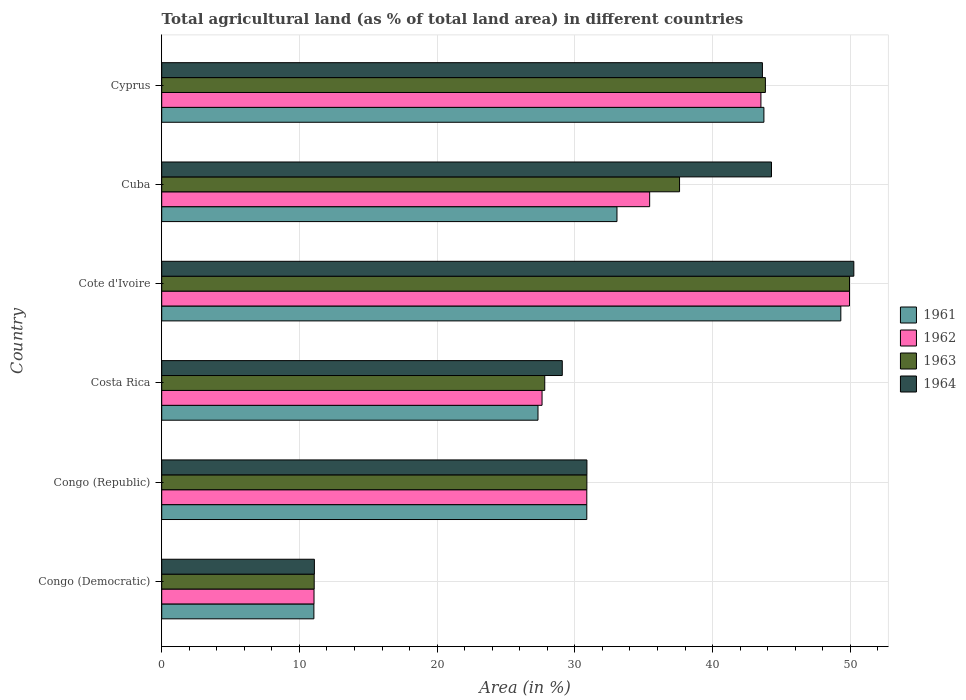How many groups of bars are there?
Provide a short and direct response. 6. How many bars are there on the 6th tick from the top?
Your response must be concise. 4. How many bars are there on the 2nd tick from the bottom?
Keep it short and to the point. 4. What is the label of the 5th group of bars from the top?
Keep it short and to the point. Congo (Republic). In how many cases, is the number of bars for a given country not equal to the number of legend labels?
Provide a short and direct response. 0. What is the percentage of agricultural land in 1961 in Congo (Republic)?
Your response must be concise. 30.86. Across all countries, what is the maximum percentage of agricultural land in 1961?
Ensure brevity in your answer.  49.31. Across all countries, what is the minimum percentage of agricultural land in 1963?
Provide a short and direct response. 11.07. In which country was the percentage of agricultural land in 1962 maximum?
Offer a very short reply. Cote d'Ivoire. In which country was the percentage of agricultural land in 1963 minimum?
Give a very brief answer. Congo (Democratic). What is the total percentage of agricultural land in 1962 in the graph?
Offer a terse response. 198.41. What is the difference between the percentage of agricultural land in 1961 in Congo (Republic) and that in Costa Rica?
Keep it short and to the point. 3.54. What is the difference between the percentage of agricultural land in 1961 in Congo (Republic) and the percentage of agricultural land in 1964 in Cyprus?
Your response must be concise. -12.75. What is the average percentage of agricultural land in 1963 per country?
Your response must be concise. 33.52. What is the difference between the percentage of agricultural land in 1961 and percentage of agricultural land in 1963 in Cyprus?
Your answer should be compact. -0.11. What is the ratio of the percentage of agricultural land in 1962 in Costa Rica to that in Cyprus?
Your response must be concise. 0.63. Is the percentage of agricultural land in 1961 in Cote d'Ivoire less than that in Cuba?
Your answer should be compact. No. What is the difference between the highest and the second highest percentage of agricultural land in 1964?
Provide a short and direct response. 5.98. What is the difference between the highest and the lowest percentage of agricultural land in 1961?
Your response must be concise. 38.26. Is the sum of the percentage of agricultural land in 1962 in Congo (Democratic) and Cuba greater than the maximum percentage of agricultural land in 1961 across all countries?
Your response must be concise. No. Is it the case that in every country, the sum of the percentage of agricultural land in 1962 and percentage of agricultural land in 1964 is greater than the sum of percentage of agricultural land in 1961 and percentage of agricultural land in 1963?
Provide a succinct answer. No. What does the 3rd bar from the top in Cyprus represents?
Offer a very short reply. 1962. How many bars are there?
Your response must be concise. 24. Are all the bars in the graph horizontal?
Your answer should be compact. Yes. Are the values on the major ticks of X-axis written in scientific E-notation?
Offer a terse response. No. Does the graph contain any zero values?
Offer a very short reply. No. Does the graph contain grids?
Your answer should be compact. Yes. What is the title of the graph?
Provide a succinct answer. Total agricultural land (as % of total land area) in different countries. Does "1965" appear as one of the legend labels in the graph?
Make the answer very short. No. What is the label or title of the X-axis?
Your answer should be compact. Area (in %). What is the Area (in %) of 1961 in Congo (Democratic)?
Offer a very short reply. 11.05. What is the Area (in %) of 1962 in Congo (Democratic)?
Provide a succinct answer. 11.06. What is the Area (in %) of 1963 in Congo (Democratic)?
Offer a terse response. 11.07. What is the Area (in %) of 1964 in Congo (Democratic)?
Give a very brief answer. 11.08. What is the Area (in %) in 1961 in Congo (Republic)?
Your response must be concise. 30.86. What is the Area (in %) of 1962 in Congo (Republic)?
Offer a terse response. 30.86. What is the Area (in %) of 1963 in Congo (Republic)?
Make the answer very short. 30.87. What is the Area (in %) of 1964 in Congo (Republic)?
Your response must be concise. 30.87. What is the Area (in %) of 1961 in Costa Rica?
Your response must be concise. 27.32. What is the Area (in %) of 1962 in Costa Rica?
Offer a terse response. 27.61. What is the Area (in %) of 1963 in Costa Rica?
Offer a very short reply. 27.81. What is the Area (in %) in 1964 in Costa Rica?
Your answer should be compact. 29.08. What is the Area (in %) in 1961 in Cote d'Ivoire?
Keep it short and to the point. 49.31. What is the Area (in %) of 1962 in Cote d'Ivoire?
Offer a very short reply. 49.94. What is the Area (in %) of 1963 in Cote d'Ivoire?
Keep it short and to the point. 49.94. What is the Area (in %) in 1964 in Cote d'Ivoire?
Your response must be concise. 50.25. What is the Area (in %) of 1961 in Cuba?
Your answer should be compact. 33.05. What is the Area (in %) in 1962 in Cuba?
Provide a short and direct response. 35.43. What is the Area (in %) in 1963 in Cuba?
Make the answer very short. 37.6. What is the Area (in %) of 1964 in Cuba?
Your answer should be very brief. 44.27. What is the Area (in %) of 1961 in Cyprus?
Ensure brevity in your answer.  43.72. What is the Area (in %) of 1962 in Cyprus?
Provide a short and direct response. 43.51. What is the Area (in %) in 1963 in Cyprus?
Keep it short and to the point. 43.83. What is the Area (in %) of 1964 in Cyprus?
Your response must be concise. 43.61. Across all countries, what is the maximum Area (in %) in 1961?
Provide a succinct answer. 49.31. Across all countries, what is the maximum Area (in %) in 1962?
Give a very brief answer. 49.94. Across all countries, what is the maximum Area (in %) of 1963?
Provide a short and direct response. 49.94. Across all countries, what is the maximum Area (in %) in 1964?
Give a very brief answer. 50.25. Across all countries, what is the minimum Area (in %) of 1961?
Give a very brief answer. 11.05. Across all countries, what is the minimum Area (in %) of 1962?
Offer a terse response. 11.06. Across all countries, what is the minimum Area (in %) in 1963?
Offer a terse response. 11.07. Across all countries, what is the minimum Area (in %) of 1964?
Your answer should be compact. 11.08. What is the total Area (in %) of 1961 in the graph?
Ensure brevity in your answer.  195.32. What is the total Area (in %) of 1962 in the graph?
Offer a very short reply. 198.41. What is the total Area (in %) of 1963 in the graph?
Ensure brevity in your answer.  201.12. What is the total Area (in %) of 1964 in the graph?
Provide a short and direct response. 209.18. What is the difference between the Area (in %) of 1961 in Congo (Democratic) and that in Congo (Republic)?
Provide a succinct answer. -19.81. What is the difference between the Area (in %) of 1962 in Congo (Democratic) and that in Congo (Republic)?
Your answer should be compact. -19.81. What is the difference between the Area (in %) in 1963 in Congo (Democratic) and that in Congo (Republic)?
Offer a terse response. -19.8. What is the difference between the Area (in %) in 1964 in Congo (Democratic) and that in Congo (Republic)?
Provide a succinct answer. -19.79. What is the difference between the Area (in %) in 1961 in Congo (Democratic) and that in Costa Rica?
Ensure brevity in your answer.  -16.27. What is the difference between the Area (in %) of 1962 in Congo (Democratic) and that in Costa Rica?
Offer a terse response. -16.56. What is the difference between the Area (in %) in 1963 in Congo (Democratic) and that in Costa Rica?
Give a very brief answer. -16.74. What is the difference between the Area (in %) in 1964 in Congo (Democratic) and that in Costa Rica?
Your answer should be very brief. -18. What is the difference between the Area (in %) of 1961 in Congo (Democratic) and that in Cote d'Ivoire?
Offer a terse response. -38.26. What is the difference between the Area (in %) in 1962 in Congo (Democratic) and that in Cote d'Ivoire?
Offer a very short reply. -38.88. What is the difference between the Area (in %) in 1963 in Congo (Democratic) and that in Cote d'Ivoire?
Your answer should be compact. -38.87. What is the difference between the Area (in %) of 1964 in Congo (Democratic) and that in Cote d'Ivoire?
Give a very brief answer. -39.17. What is the difference between the Area (in %) of 1961 in Congo (Democratic) and that in Cuba?
Provide a succinct answer. -22. What is the difference between the Area (in %) in 1962 in Congo (Democratic) and that in Cuba?
Provide a short and direct response. -24.37. What is the difference between the Area (in %) in 1963 in Congo (Democratic) and that in Cuba?
Keep it short and to the point. -26.53. What is the difference between the Area (in %) in 1964 in Congo (Democratic) and that in Cuba?
Provide a succinct answer. -33.19. What is the difference between the Area (in %) in 1961 in Congo (Democratic) and that in Cyprus?
Your answer should be compact. -32.67. What is the difference between the Area (in %) in 1962 in Congo (Democratic) and that in Cyprus?
Make the answer very short. -32.45. What is the difference between the Area (in %) of 1963 in Congo (Democratic) and that in Cyprus?
Your answer should be compact. -32.76. What is the difference between the Area (in %) in 1964 in Congo (Democratic) and that in Cyprus?
Provide a succinct answer. -32.53. What is the difference between the Area (in %) of 1961 in Congo (Republic) and that in Costa Rica?
Your answer should be very brief. 3.54. What is the difference between the Area (in %) in 1962 in Congo (Republic) and that in Costa Rica?
Offer a very short reply. 3.25. What is the difference between the Area (in %) of 1963 in Congo (Republic) and that in Costa Rica?
Offer a terse response. 3.06. What is the difference between the Area (in %) in 1964 in Congo (Republic) and that in Costa Rica?
Ensure brevity in your answer.  1.79. What is the difference between the Area (in %) in 1961 in Congo (Republic) and that in Cote d'Ivoire?
Give a very brief answer. -18.44. What is the difference between the Area (in %) in 1962 in Congo (Republic) and that in Cote d'Ivoire?
Provide a succinct answer. -19.07. What is the difference between the Area (in %) of 1963 in Congo (Republic) and that in Cote d'Ivoire?
Give a very brief answer. -19.07. What is the difference between the Area (in %) in 1964 in Congo (Republic) and that in Cote d'Ivoire?
Keep it short and to the point. -19.38. What is the difference between the Area (in %) in 1961 in Congo (Republic) and that in Cuba?
Keep it short and to the point. -2.19. What is the difference between the Area (in %) of 1962 in Congo (Republic) and that in Cuba?
Keep it short and to the point. -4.56. What is the difference between the Area (in %) of 1963 in Congo (Republic) and that in Cuba?
Give a very brief answer. -6.73. What is the difference between the Area (in %) in 1964 in Congo (Republic) and that in Cuba?
Keep it short and to the point. -13.4. What is the difference between the Area (in %) in 1961 in Congo (Republic) and that in Cyprus?
Your answer should be compact. -12.86. What is the difference between the Area (in %) of 1962 in Congo (Republic) and that in Cyprus?
Offer a terse response. -12.64. What is the difference between the Area (in %) in 1963 in Congo (Republic) and that in Cyprus?
Offer a terse response. -12.96. What is the difference between the Area (in %) in 1964 in Congo (Republic) and that in Cyprus?
Offer a very short reply. -12.74. What is the difference between the Area (in %) of 1961 in Costa Rica and that in Cote d'Ivoire?
Your answer should be very brief. -21.99. What is the difference between the Area (in %) of 1962 in Costa Rica and that in Cote d'Ivoire?
Provide a short and direct response. -22.32. What is the difference between the Area (in %) in 1963 in Costa Rica and that in Cote d'Ivoire?
Keep it short and to the point. -22.13. What is the difference between the Area (in %) of 1964 in Costa Rica and that in Cote d'Ivoire?
Offer a terse response. -21.17. What is the difference between the Area (in %) in 1961 in Costa Rica and that in Cuba?
Offer a terse response. -5.73. What is the difference between the Area (in %) of 1962 in Costa Rica and that in Cuba?
Give a very brief answer. -7.81. What is the difference between the Area (in %) in 1963 in Costa Rica and that in Cuba?
Offer a very short reply. -9.79. What is the difference between the Area (in %) in 1964 in Costa Rica and that in Cuba?
Ensure brevity in your answer.  -15.19. What is the difference between the Area (in %) of 1961 in Costa Rica and that in Cyprus?
Offer a very short reply. -16.4. What is the difference between the Area (in %) of 1962 in Costa Rica and that in Cyprus?
Give a very brief answer. -15.89. What is the difference between the Area (in %) in 1963 in Costa Rica and that in Cyprus?
Make the answer very short. -16.02. What is the difference between the Area (in %) in 1964 in Costa Rica and that in Cyprus?
Your answer should be very brief. -14.53. What is the difference between the Area (in %) in 1961 in Cote d'Ivoire and that in Cuba?
Give a very brief answer. 16.25. What is the difference between the Area (in %) in 1962 in Cote d'Ivoire and that in Cuba?
Offer a terse response. 14.51. What is the difference between the Area (in %) of 1963 in Cote d'Ivoire and that in Cuba?
Ensure brevity in your answer.  12.34. What is the difference between the Area (in %) in 1964 in Cote d'Ivoire and that in Cuba?
Give a very brief answer. 5.98. What is the difference between the Area (in %) in 1961 in Cote d'Ivoire and that in Cyprus?
Your answer should be compact. 5.59. What is the difference between the Area (in %) of 1962 in Cote d'Ivoire and that in Cyprus?
Make the answer very short. 6.43. What is the difference between the Area (in %) in 1963 in Cote d'Ivoire and that in Cyprus?
Offer a very short reply. 6.11. What is the difference between the Area (in %) of 1964 in Cote d'Ivoire and that in Cyprus?
Your answer should be very brief. 6.64. What is the difference between the Area (in %) of 1961 in Cuba and that in Cyprus?
Make the answer very short. -10.67. What is the difference between the Area (in %) in 1962 in Cuba and that in Cyprus?
Provide a short and direct response. -8.08. What is the difference between the Area (in %) of 1963 in Cuba and that in Cyprus?
Your answer should be compact. -6.23. What is the difference between the Area (in %) of 1964 in Cuba and that in Cyprus?
Keep it short and to the point. 0.66. What is the difference between the Area (in %) of 1961 in Congo (Democratic) and the Area (in %) of 1962 in Congo (Republic)?
Your answer should be very brief. -19.81. What is the difference between the Area (in %) in 1961 in Congo (Democratic) and the Area (in %) in 1963 in Congo (Republic)?
Make the answer very short. -19.82. What is the difference between the Area (in %) in 1961 in Congo (Democratic) and the Area (in %) in 1964 in Congo (Republic)?
Offer a terse response. -19.82. What is the difference between the Area (in %) in 1962 in Congo (Democratic) and the Area (in %) in 1963 in Congo (Republic)?
Ensure brevity in your answer.  -19.81. What is the difference between the Area (in %) of 1962 in Congo (Democratic) and the Area (in %) of 1964 in Congo (Republic)?
Give a very brief answer. -19.81. What is the difference between the Area (in %) of 1963 in Congo (Democratic) and the Area (in %) of 1964 in Congo (Republic)?
Provide a short and direct response. -19.8. What is the difference between the Area (in %) of 1961 in Congo (Democratic) and the Area (in %) of 1962 in Costa Rica?
Keep it short and to the point. -16.57. What is the difference between the Area (in %) in 1961 in Congo (Democratic) and the Area (in %) in 1963 in Costa Rica?
Keep it short and to the point. -16.76. What is the difference between the Area (in %) of 1961 in Congo (Democratic) and the Area (in %) of 1964 in Costa Rica?
Ensure brevity in your answer.  -18.03. What is the difference between the Area (in %) in 1962 in Congo (Democratic) and the Area (in %) in 1963 in Costa Rica?
Your response must be concise. -16.75. What is the difference between the Area (in %) in 1962 in Congo (Democratic) and the Area (in %) in 1964 in Costa Rica?
Offer a very short reply. -18.02. What is the difference between the Area (in %) in 1963 in Congo (Democratic) and the Area (in %) in 1964 in Costa Rica?
Your answer should be compact. -18.01. What is the difference between the Area (in %) in 1961 in Congo (Democratic) and the Area (in %) in 1962 in Cote d'Ivoire?
Give a very brief answer. -38.89. What is the difference between the Area (in %) in 1961 in Congo (Democratic) and the Area (in %) in 1963 in Cote d'Ivoire?
Provide a short and direct response. -38.89. What is the difference between the Area (in %) in 1961 in Congo (Democratic) and the Area (in %) in 1964 in Cote d'Ivoire?
Offer a very short reply. -39.2. What is the difference between the Area (in %) in 1962 in Congo (Democratic) and the Area (in %) in 1963 in Cote d'Ivoire?
Offer a very short reply. -38.88. What is the difference between the Area (in %) of 1962 in Congo (Democratic) and the Area (in %) of 1964 in Cote d'Ivoire?
Your response must be concise. -39.19. What is the difference between the Area (in %) in 1963 in Congo (Democratic) and the Area (in %) in 1964 in Cote d'Ivoire?
Make the answer very short. -39.18. What is the difference between the Area (in %) in 1961 in Congo (Democratic) and the Area (in %) in 1962 in Cuba?
Provide a succinct answer. -24.38. What is the difference between the Area (in %) in 1961 in Congo (Democratic) and the Area (in %) in 1963 in Cuba?
Offer a terse response. -26.55. What is the difference between the Area (in %) in 1961 in Congo (Democratic) and the Area (in %) in 1964 in Cuba?
Provide a succinct answer. -33.22. What is the difference between the Area (in %) in 1962 in Congo (Democratic) and the Area (in %) in 1963 in Cuba?
Your response must be concise. -26.54. What is the difference between the Area (in %) of 1962 in Congo (Democratic) and the Area (in %) of 1964 in Cuba?
Your answer should be compact. -33.22. What is the difference between the Area (in %) in 1963 in Congo (Democratic) and the Area (in %) in 1964 in Cuba?
Provide a succinct answer. -33.2. What is the difference between the Area (in %) of 1961 in Congo (Democratic) and the Area (in %) of 1962 in Cyprus?
Your answer should be very brief. -32.46. What is the difference between the Area (in %) in 1961 in Congo (Democratic) and the Area (in %) in 1963 in Cyprus?
Give a very brief answer. -32.78. What is the difference between the Area (in %) of 1961 in Congo (Democratic) and the Area (in %) of 1964 in Cyprus?
Your answer should be compact. -32.57. What is the difference between the Area (in %) of 1962 in Congo (Democratic) and the Area (in %) of 1963 in Cyprus?
Your answer should be very brief. -32.77. What is the difference between the Area (in %) in 1962 in Congo (Democratic) and the Area (in %) in 1964 in Cyprus?
Ensure brevity in your answer.  -32.56. What is the difference between the Area (in %) in 1963 in Congo (Democratic) and the Area (in %) in 1964 in Cyprus?
Offer a very short reply. -32.54. What is the difference between the Area (in %) of 1961 in Congo (Republic) and the Area (in %) of 1962 in Costa Rica?
Keep it short and to the point. 3.25. What is the difference between the Area (in %) in 1961 in Congo (Republic) and the Area (in %) in 1963 in Costa Rica?
Your response must be concise. 3.05. What is the difference between the Area (in %) of 1961 in Congo (Republic) and the Area (in %) of 1964 in Costa Rica?
Offer a terse response. 1.78. What is the difference between the Area (in %) of 1962 in Congo (Republic) and the Area (in %) of 1963 in Costa Rica?
Provide a succinct answer. 3.05. What is the difference between the Area (in %) in 1962 in Congo (Republic) and the Area (in %) in 1964 in Costa Rica?
Your answer should be compact. 1.78. What is the difference between the Area (in %) in 1963 in Congo (Republic) and the Area (in %) in 1964 in Costa Rica?
Offer a very short reply. 1.79. What is the difference between the Area (in %) in 1961 in Congo (Republic) and the Area (in %) in 1962 in Cote d'Ivoire?
Offer a very short reply. -19.07. What is the difference between the Area (in %) of 1961 in Congo (Republic) and the Area (in %) of 1963 in Cote d'Ivoire?
Provide a succinct answer. -19.07. What is the difference between the Area (in %) in 1961 in Congo (Republic) and the Area (in %) in 1964 in Cote d'Ivoire?
Make the answer very short. -19.39. What is the difference between the Area (in %) of 1962 in Congo (Republic) and the Area (in %) of 1963 in Cote d'Ivoire?
Provide a succinct answer. -19.07. What is the difference between the Area (in %) of 1962 in Congo (Republic) and the Area (in %) of 1964 in Cote d'Ivoire?
Keep it short and to the point. -19.39. What is the difference between the Area (in %) of 1963 in Congo (Republic) and the Area (in %) of 1964 in Cote d'Ivoire?
Your response must be concise. -19.38. What is the difference between the Area (in %) in 1961 in Congo (Republic) and the Area (in %) in 1962 in Cuba?
Offer a terse response. -4.56. What is the difference between the Area (in %) of 1961 in Congo (Republic) and the Area (in %) of 1963 in Cuba?
Offer a terse response. -6.73. What is the difference between the Area (in %) in 1961 in Congo (Republic) and the Area (in %) in 1964 in Cuba?
Your answer should be compact. -13.41. What is the difference between the Area (in %) in 1962 in Congo (Republic) and the Area (in %) in 1963 in Cuba?
Your answer should be very brief. -6.73. What is the difference between the Area (in %) of 1962 in Congo (Republic) and the Area (in %) of 1964 in Cuba?
Keep it short and to the point. -13.41. What is the difference between the Area (in %) of 1963 in Congo (Republic) and the Area (in %) of 1964 in Cuba?
Your response must be concise. -13.4. What is the difference between the Area (in %) of 1961 in Congo (Republic) and the Area (in %) of 1962 in Cyprus?
Keep it short and to the point. -12.64. What is the difference between the Area (in %) of 1961 in Congo (Republic) and the Area (in %) of 1963 in Cyprus?
Offer a terse response. -12.97. What is the difference between the Area (in %) of 1961 in Congo (Republic) and the Area (in %) of 1964 in Cyprus?
Your answer should be very brief. -12.75. What is the difference between the Area (in %) of 1962 in Congo (Republic) and the Area (in %) of 1963 in Cyprus?
Give a very brief answer. -12.97. What is the difference between the Area (in %) in 1962 in Congo (Republic) and the Area (in %) in 1964 in Cyprus?
Keep it short and to the point. -12.75. What is the difference between the Area (in %) of 1963 in Congo (Republic) and the Area (in %) of 1964 in Cyprus?
Your answer should be compact. -12.74. What is the difference between the Area (in %) in 1961 in Costa Rica and the Area (in %) in 1962 in Cote d'Ivoire?
Ensure brevity in your answer.  -22.62. What is the difference between the Area (in %) in 1961 in Costa Rica and the Area (in %) in 1963 in Cote d'Ivoire?
Keep it short and to the point. -22.62. What is the difference between the Area (in %) in 1961 in Costa Rica and the Area (in %) in 1964 in Cote d'Ivoire?
Offer a very short reply. -22.93. What is the difference between the Area (in %) of 1962 in Costa Rica and the Area (in %) of 1963 in Cote d'Ivoire?
Give a very brief answer. -22.32. What is the difference between the Area (in %) in 1962 in Costa Rica and the Area (in %) in 1964 in Cote d'Ivoire?
Your answer should be very brief. -22.64. What is the difference between the Area (in %) of 1963 in Costa Rica and the Area (in %) of 1964 in Cote d'Ivoire?
Offer a terse response. -22.44. What is the difference between the Area (in %) of 1961 in Costa Rica and the Area (in %) of 1962 in Cuba?
Your answer should be very brief. -8.11. What is the difference between the Area (in %) in 1961 in Costa Rica and the Area (in %) in 1963 in Cuba?
Ensure brevity in your answer.  -10.28. What is the difference between the Area (in %) of 1961 in Costa Rica and the Area (in %) of 1964 in Cuba?
Your answer should be very brief. -16.95. What is the difference between the Area (in %) of 1962 in Costa Rica and the Area (in %) of 1963 in Cuba?
Offer a very short reply. -9.98. What is the difference between the Area (in %) of 1962 in Costa Rica and the Area (in %) of 1964 in Cuba?
Provide a short and direct response. -16.66. What is the difference between the Area (in %) in 1963 in Costa Rica and the Area (in %) in 1964 in Cuba?
Offer a very short reply. -16.46. What is the difference between the Area (in %) in 1961 in Costa Rica and the Area (in %) in 1962 in Cyprus?
Keep it short and to the point. -16.19. What is the difference between the Area (in %) of 1961 in Costa Rica and the Area (in %) of 1963 in Cyprus?
Provide a succinct answer. -16.51. What is the difference between the Area (in %) of 1961 in Costa Rica and the Area (in %) of 1964 in Cyprus?
Offer a very short reply. -16.29. What is the difference between the Area (in %) in 1962 in Costa Rica and the Area (in %) in 1963 in Cyprus?
Provide a short and direct response. -16.22. What is the difference between the Area (in %) of 1962 in Costa Rica and the Area (in %) of 1964 in Cyprus?
Provide a short and direct response. -16. What is the difference between the Area (in %) of 1963 in Costa Rica and the Area (in %) of 1964 in Cyprus?
Your answer should be very brief. -15.8. What is the difference between the Area (in %) of 1961 in Cote d'Ivoire and the Area (in %) of 1962 in Cuba?
Ensure brevity in your answer.  13.88. What is the difference between the Area (in %) of 1961 in Cote d'Ivoire and the Area (in %) of 1963 in Cuba?
Give a very brief answer. 11.71. What is the difference between the Area (in %) in 1961 in Cote d'Ivoire and the Area (in %) in 1964 in Cuba?
Offer a very short reply. 5.03. What is the difference between the Area (in %) in 1962 in Cote d'Ivoire and the Area (in %) in 1963 in Cuba?
Make the answer very short. 12.34. What is the difference between the Area (in %) in 1962 in Cote d'Ivoire and the Area (in %) in 1964 in Cuba?
Your answer should be compact. 5.66. What is the difference between the Area (in %) in 1963 in Cote d'Ivoire and the Area (in %) in 1964 in Cuba?
Keep it short and to the point. 5.66. What is the difference between the Area (in %) of 1961 in Cote d'Ivoire and the Area (in %) of 1962 in Cyprus?
Offer a very short reply. 5.8. What is the difference between the Area (in %) in 1961 in Cote d'Ivoire and the Area (in %) in 1963 in Cyprus?
Offer a very short reply. 5.48. What is the difference between the Area (in %) of 1961 in Cote d'Ivoire and the Area (in %) of 1964 in Cyprus?
Your answer should be compact. 5.69. What is the difference between the Area (in %) in 1962 in Cote d'Ivoire and the Area (in %) in 1963 in Cyprus?
Make the answer very short. 6.11. What is the difference between the Area (in %) in 1962 in Cote d'Ivoire and the Area (in %) in 1964 in Cyprus?
Your answer should be very brief. 6.32. What is the difference between the Area (in %) of 1963 in Cote d'Ivoire and the Area (in %) of 1964 in Cyprus?
Ensure brevity in your answer.  6.32. What is the difference between the Area (in %) in 1961 in Cuba and the Area (in %) in 1962 in Cyprus?
Offer a very short reply. -10.45. What is the difference between the Area (in %) in 1961 in Cuba and the Area (in %) in 1963 in Cyprus?
Give a very brief answer. -10.78. What is the difference between the Area (in %) of 1961 in Cuba and the Area (in %) of 1964 in Cyprus?
Offer a very short reply. -10.56. What is the difference between the Area (in %) in 1962 in Cuba and the Area (in %) in 1963 in Cyprus?
Offer a terse response. -8.4. What is the difference between the Area (in %) in 1962 in Cuba and the Area (in %) in 1964 in Cyprus?
Ensure brevity in your answer.  -8.19. What is the difference between the Area (in %) in 1963 in Cuba and the Area (in %) in 1964 in Cyprus?
Make the answer very short. -6.02. What is the average Area (in %) of 1961 per country?
Your answer should be very brief. 32.55. What is the average Area (in %) of 1962 per country?
Offer a very short reply. 33.07. What is the average Area (in %) of 1963 per country?
Your answer should be compact. 33.52. What is the average Area (in %) of 1964 per country?
Your response must be concise. 34.86. What is the difference between the Area (in %) in 1961 and Area (in %) in 1962 in Congo (Democratic)?
Ensure brevity in your answer.  -0.01. What is the difference between the Area (in %) of 1961 and Area (in %) of 1963 in Congo (Democratic)?
Keep it short and to the point. -0.02. What is the difference between the Area (in %) of 1961 and Area (in %) of 1964 in Congo (Democratic)?
Offer a very short reply. -0.04. What is the difference between the Area (in %) of 1962 and Area (in %) of 1963 in Congo (Democratic)?
Ensure brevity in your answer.  -0.01. What is the difference between the Area (in %) of 1962 and Area (in %) of 1964 in Congo (Democratic)?
Offer a terse response. -0.03. What is the difference between the Area (in %) in 1963 and Area (in %) in 1964 in Congo (Democratic)?
Your answer should be very brief. -0.01. What is the difference between the Area (in %) of 1961 and Area (in %) of 1963 in Congo (Republic)?
Provide a succinct answer. -0.01. What is the difference between the Area (in %) in 1961 and Area (in %) in 1964 in Congo (Republic)?
Keep it short and to the point. -0.01. What is the difference between the Area (in %) in 1962 and Area (in %) in 1963 in Congo (Republic)?
Your answer should be compact. -0.01. What is the difference between the Area (in %) in 1962 and Area (in %) in 1964 in Congo (Republic)?
Your answer should be very brief. -0.01. What is the difference between the Area (in %) of 1963 and Area (in %) of 1964 in Congo (Republic)?
Offer a very short reply. -0. What is the difference between the Area (in %) in 1961 and Area (in %) in 1962 in Costa Rica?
Offer a very short reply. -0.29. What is the difference between the Area (in %) in 1961 and Area (in %) in 1963 in Costa Rica?
Provide a short and direct response. -0.49. What is the difference between the Area (in %) in 1961 and Area (in %) in 1964 in Costa Rica?
Offer a very short reply. -1.76. What is the difference between the Area (in %) in 1962 and Area (in %) in 1963 in Costa Rica?
Your response must be concise. -0.2. What is the difference between the Area (in %) of 1962 and Area (in %) of 1964 in Costa Rica?
Keep it short and to the point. -1.47. What is the difference between the Area (in %) of 1963 and Area (in %) of 1964 in Costa Rica?
Keep it short and to the point. -1.27. What is the difference between the Area (in %) in 1961 and Area (in %) in 1962 in Cote d'Ivoire?
Offer a terse response. -0.63. What is the difference between the Area (in %) of 1961 and Area (in %) of 1963 in Cote d'Ivoire?
Your response must be concise. -0.63. What is the difference between the Area (in %) in 1961 and Area (in %) in 1964 in Cote d'Ivoire?
Keep it short and to the point. -0.94. What is the difference between the Area (in %) of 1962 and Area (in %) of 1964 in Cote d'Ivoire?
Give a very brief answer. -0.31. What is the difference between the Area (in %) in 1963 and Area (in %) in 1964 in Cote d'Ivoire?
Your answer should be very brief. -0.31. What is the difference between the Area (in %) of 1961 and Area (in %) of 1962 in Cuba?
Provide a short and direct response. -2.37. What is the difference between the Area (in %) in 1961 and Area (in %) in 1963 in Cuba?
Keep it short and to the point. -4.54. What is the difference between the Area (in %) of 1961 and Area (in %) of 1964 in Cuba?
Your answer should be compact. -11.22. What is the difference between the Area (in %) of 1962 and Area (in %) of 1963 in Cuba?
Your answer should be very brief. -2.17. What is the difference between the Area (in %) in 1962 and Area (in %) in 1964 in Cuba?
Keep it short and to the point. -8.85. What is the difference between the Area (in %) in 1963 and Area (in %) in 1964 in Cuba?
Ensure brevity in your answer.  -6.68. What is the difference between the Area (in %) of 1961 and Area (in %) of 1962 in Cyprus?
Make the answer very short. 0.22. What is the difference between the Area (in %) of 1961 and Area (in %) of 1963 in Cyprus?
Your response must be concise. -0.11. What is the difference between the Area (in %) in 1961 and Area (in %) in 1964 in Cyprus?
Keep it short and to the point. 0.11. What is the difference between the Area (in %) in 1962 and Area (in %) in 1963 in Cyprus?
Provide a succinct answer. -0.32. What is the difference between the Area (in %) in 1962 and Area (in %) in 1964 in Cyprus?
Offer a terse response. -0.11. What is the difference between the Area (in %) in 1963 and Area (in %) in 1964 in Cyprus?
Your answer should be compact. 0.22. What is the ratio of the Area (in %) in 1961 in Congo (Democratic) to that in Congo (Republic)?
Your answer should be compact. 0.36. What is the ratio of the Area (in %) in 1962 in Congo (Democratic) to that in Congo (Republic)?
Your response must be concise. 0.36. What is the ratio of the Area (in %) of 1963 in Congo (Democratic) to that in Congo (Republic)?
Keep it short and to the point. 0.36. What is the ratio of the Area (in %) in 1964 in Congo (Democratic) to that in Congo (Republic)?
Make the answer very short. 0.36. What is the ratio of the Area (in %) of 1961 in Congo (Democratic) to that in Costa Rica?
Offer a terse response. 0.4. What is the ratio of the Area (in %) in 1962 in Congo (Democratic) to that in Costa Rica?
Make the answer very short. 0.4. What is the ratio of the Area (in %) of 1963 in Congo (Democratic) to that in Costa Rica?
Make the answer very short. 0.4. What is the ratio of the Area (in %) of 1964 in Congo (Democratic) to that in Costa Rica?
Keep it short and to the point. 0.38. What is the ratio of the Area (in %) of 1961 in Congo (Democratic) to that in Cote d'Ivoire?
Offer a terse response. 0.22. What is the ratio of the Area (in %) in 1962 in Congo (Democratic) to that in Cote d'Ivoire?
Offer a very short reply. 0.22. What is the ratio of the Area (in %) of 1963 in Congo (Democratic) to that in Cote d'Ivoire?
Provide a succinct answer. 0.22. What is the ratio of the Area (in %) of 1964 in Congo (Democratic) to that in Cote d'Ivoire?
Offer a very short reply. 0.22. What is the ratio of the Area (in %) in 1961 in Congo (Democratic) to that in Cuba?
Your response must be concise. 0.33. What is the ratio of the Area (in %) of 1962 in Congo (Democratic) to that in Cuba?
Keep it short and to the point. 0.31. What is the ratio of the Area (in %) of 1963 in Congo (Democratic) to that in Cuba?
Ensure brevity in your answer.  0.29. What is the ratio of the Area (in %) of 1964 in Congo (Democratic) to that in Cuba?
Offer a very short reply. 0.25. What is the ratio of the Area (in %) of 1961 in Congo (Democratic) to that in Cyprus?
Provide a short and direct response. 0.25. What is the ratio of the Area (in %) of 1962 in Congo (Democratic) to that in Cyprus?
Provide a succinct answer. 0.25. What is the ratio of the Area (in %) of 1963 in Congo (Democratic) to that in Cyprus?
Give a very brief answer. 0.25. What is the ratio of the Area (in %) of 1964 in Congo (Democratic) to that in Cyprus?
Ensure brevity in your answer.  0.25. What is the ratio of the Area (in %) in 1961 in Congo (Republic) to that in Costa Rica?
Offer a terse response. 1.13. What is the ratio of the Area (in %) in 1962 in Congo (Republic) to that in Costa Rica?
Your answer should be compact. 1.12. What is the ratio of the Area (in %) of 1963 in Congo (Republic) to that in Costa Rica?
Ensure brevity in your answer.  1.11. What is the ratio of the Area (in %) of 1964 in Congo (Republic) to that in Costa Rica?
Your response must be concise. 1.06. What is the ratio of the Area (in %) of 1961 in Congo (Republic) to that in Cote d'Ivoire?
Keep it short and to the point. 0.63. What is the ratio of the Area (in %) of 1962 in Congo (Republic) to that in Cote d'Ivoire?
Your answer should be very brief. 0.62. What is the ratio of the Area (in %) in 1963 in Congo (Republic) to that in Cote d'Ivoire?
Your response must be concise. 0.62. What is the ratio of the Area (in %) of 1964 in Congo (Republic) to that in Cote d'Ivoire?
Your response must be concise. 0.61. What is the ratio of the Area (in %) of 1961 in Congo (Republic) to that in Cuba?
Offer a terse response. 0.93. What is the ratio of the Area (in %) of 1962 in Congo (Republic) to that in Cuba?
Give a very brief answer. 0.87. What is the ratio of the Area (in %) of 1963 in Congo (Republic) to that in Cuba?
Give a very brief answer. 0.82. What is the ratio of the Area (in %) in 1964 in Congo (Republic) to that in Cuba?
Keep it short and to the point. 0.7. What is the ratio of the Area (in %) of 1961 in Congo (Republic) to that in Cyprus?
Offer a very short reply. 0.71. What is the ratio of the Area (in %) in 1962 in Congo (Republic) to that in Cyprus?
Provide a succinct answer. 0.71. What is the ratio of the Area (in %) in 1963 in Congo (Republic) to that in Cyprus?
Your answer should be very brief. 0.7. What is the ratio of the Area (in %) in 1964 in Congo (Republic) to that in Cyprus?
Ensure brevity in your answer.  0.71. What is the ratio of the Area (in %) in 1961 in Costa Rica to that in Cote d'Ivoire?
Ensure brevity in your answer.  0.55. What is the ratio of the Area (in %) in 1962 in Costa Rica to that in Cote d'Ivoire?
Make the answer very short. 0.55. What is the ratio of the Area (in %) in 1963 in Costa Rica to that in Cote d'Ivoire?
Your response must be concise. 0.56. What is the ratio of the Area (in %) in 1964 in Costa Rica to that in Cote d'Ivoire?
Ensure brevity in your answer.  0.58. What is the ratio of the Area (in %) in 1961 in Costa Rica to that in Cuba?
Your response must be concise. 0.83. What is the ratio of the Area (in %) of 1962 in Costa Rica to that in Cuba?
Give a very brief answer. 0.78. What is the ratio of the Area (in %) of 1963 in Costa Rica to that in Cuba?
Make the answer very short. 0.74. What is the ratio of the Area (in %) in 1964 in Costa Rica to that in Cuba?
Provide a succinct answer. 0.66. What is the ratio of the Area (in %) in 1961 in Costa Rica to that in Cyprus?
Ensure brevity in your answer.  0.62. What is the ratio of the Area (in %) in 1962 in Costa Rica to that in Cyprus?
Provide a short and direct response. 0.63. What is the ratio of the Area (in %) in 1963 in Costa Rica to that in Cyprus?
Ensure brevity in your answer.  0.63. What is the ratio of the Area (in %) of 1964 in Costa Rica to that in Cyprus?
Keep it short and to the point. 0.67. What is the ratio of the Area (in %) in 1961 in Cote d'Ivoire to that in Cuba?
Give a very brief answer. 1.49. What is the ratio of the Area (in %) in 1962 in Cote d'Ivoire to that in Cuba?
Ensure brevity in your answer.  1.41. What is the ratio of the Area (in %) of 1963 in Cote d'Ivoire to that in Cuba?
Keep it short and to the point. 1.33. What is the ratio of the Area (in %) of 1964 in Cote d'Ivoire to that in Cuba?
Give a very brief answer. 1.14. What is the ratio of the Area (in %) in 1961 in Cote d'Ivoire to that in Cyprus?
Offer a very short reply. 1.13. What is the ratio of the Area (in %) of 1962 in Cote d'Ivoire to that in Cyprus?
Provide a succinct answer. 1.15. What is the ratio of the Area (in %) of 1963 in Cote d'Ivoire to that in Cyprus?
Ensure brevity in your answer.  1.14. What is the ratio of the Area (in %) in 1964 in Cote d'Ivoire to that in Cyprus?
Your response must be concise. 1.15. What is the ratio of the Area (in %) in 1961 in Cuba to that in Cyprus?
Offer a very short reply. 0.76. What is the ratio of the Area (in %) of 1962 in Cuba to that in Cyprus?
Make the answer very short. 0.81. What is the ratio of the Area (in %) in 1963 in Cuba to that in Cyprus?
Keep it short and to the point. 0.86. What is the ratio of the Area (in %) in 1964 in Cuba to that in Cyprus?
Your answer should be compact. 1.02. What is the difference between the highest and the second highest Area (in %) of 1961?
Offer a terse response. 5.59. What is the difference between the highest and the second highest Area (in %) in 1962?
Keep it short and to the point. 6.43. What is the difference between the highest and the second highest Area (in %) of 1963?
Ensure brevity in your answer.  6.11. What is the difference between the highest and the second highest Area (in %) in 1964?
Offer a terse response. 5.98. What is the difference between the highest and the lowest Area (in %) in 1961?
Provide a short and direct response. 38.26. What is the difference between the highest and the lowest Area (in %) in 1962?
Your response must be concise. 38.88. What is the difference between the highest and the lowest Area (in %) of 1963?
Ensure brevity in your answer.  38.87. What is the difference between the highest and the lowest Area (in %) of 1964?
Your answer should be compact. 39.17. 